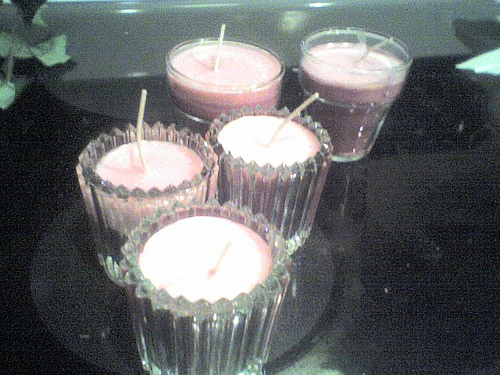<image>
Is there a straw in the glass? No. The straw is not contained within the glass. These objects have a different spatial relationship. 